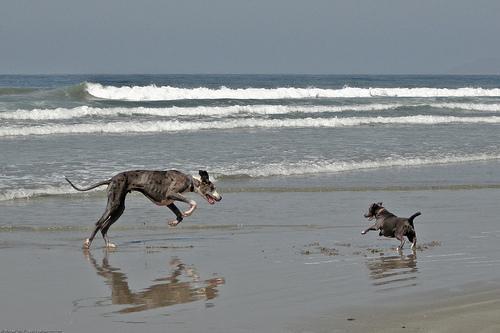How many dogs playing?
Give a very brief answer. 2. 